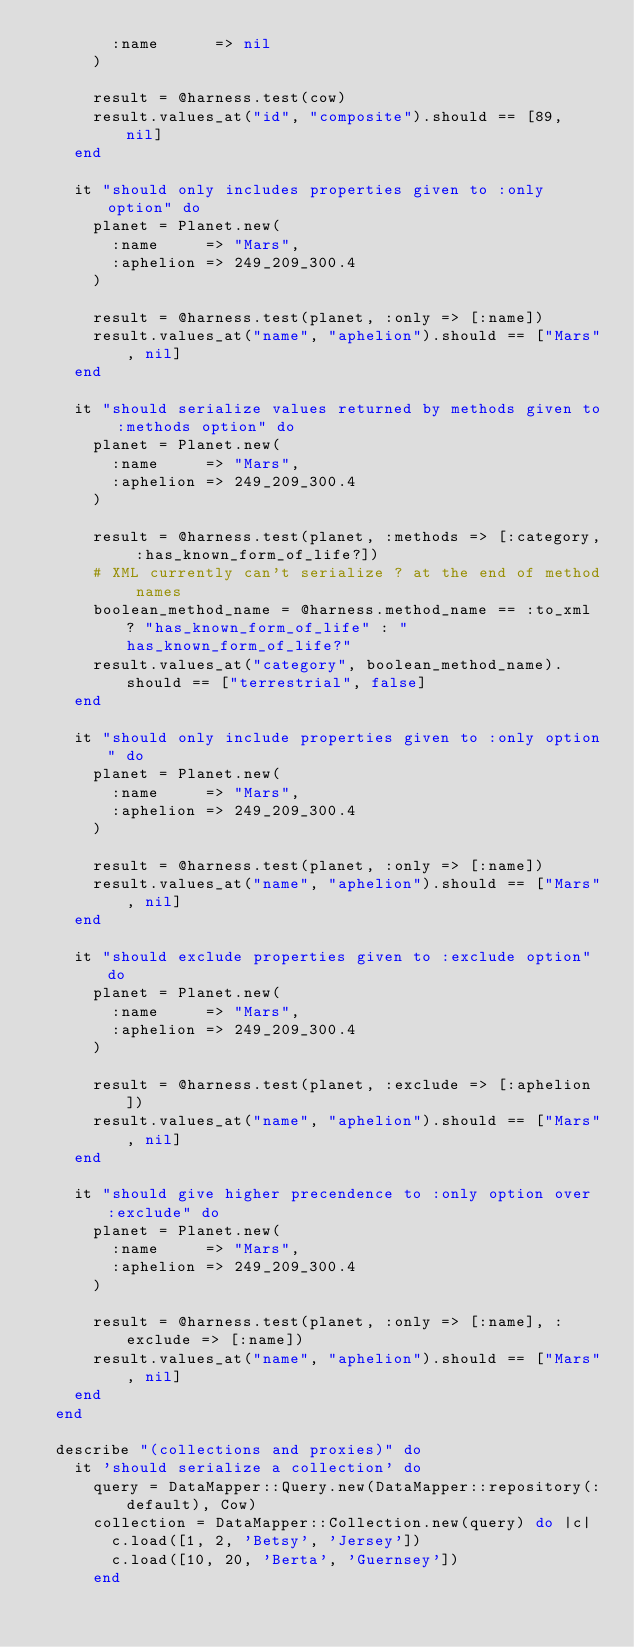<code> <loc_0><loc_0><loc_500><loc_500><_Ruby_>        :name      => nil
      )
      
      result = @harness.test(cow)
      result.values_at("id", "composite").should == [89,  nil]
    end

    it "should only includes properties given to :only option" do
      planet = Planet.new(
        :name     => "Mars",
        :aphelion => 249_209_300.4
      )

      result = @harness.test(planet, :only => [:name])
      result.values_at("name", "aphelion").should == ["Mars", nil]
    end

    it "should serialize values returned by methods given to :methods option" do
      planet = Planet.new(
        :name     => "Mars",
        :aphelion => 249_209_300.4
      )

      result = @harness.test(planet, :methods => [:category, :has_known_form_of_life?])
      # XML currently can't serialize ? at the end of method names
      boolean_method_name = @harness.method_name == :to_xml ? "has_known_form_of_life" : "has_known_form_of_life?"
      result.values_at("category", boolean_method_name).should == ["terrestrial", false]
    end

    it "should only include properties given to :only option" do
      planet = Planet.new(
        :name     => "Mars",
        :aphelion => 249_209_300.4
      )

      result = @harness.test(planet, :only => [:name])
      result.values_at("name", "aphelion").should == ["Mars", nil]
    end

    it "should exclude properties given to :exclude option" do
      planet = Planet.new(
        :name     => "Mars",
        :aphelion => 249_209_300.4
      )

      result = @harness.test(planet, :exclude => [:aphelion])
      result.values_at("name", "aphelion").should == ["Mars", nil]
    end

    it "should give higher precendence to :only option over :exclude" do
      planet = Planet.new(
        :name     => "Mars",
        :aphelion => 249_209_300.4
      )

      result = @harness.test(planet, :only => [:name], :exclude => [:name])
      result.values_at("name", "aphelion").should == ["Mars", nil]
    end
  end

  describe "(collections and proxies)" do
    it 'should serialize a collection' do
      query = DataMapper::Query.new(DataMapper::repository(:default), Cow)
      collection = DataMapper::Collection.new(query) do |c|
        c.load([1, 2, 'Betsy', 'Jersey'])
        c.load([10, 20, 'Berta', 'Guernsey'])
      end
</code> 